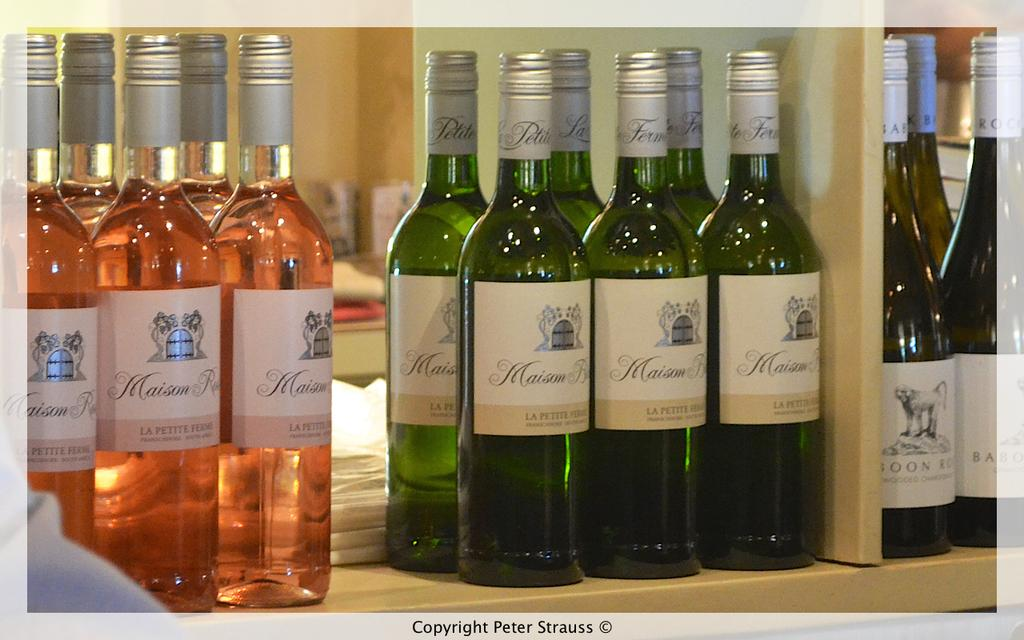<image>
Share a concise interpretation of the image provided. bottles of wine in different groups of colors all labeled Maison on them 